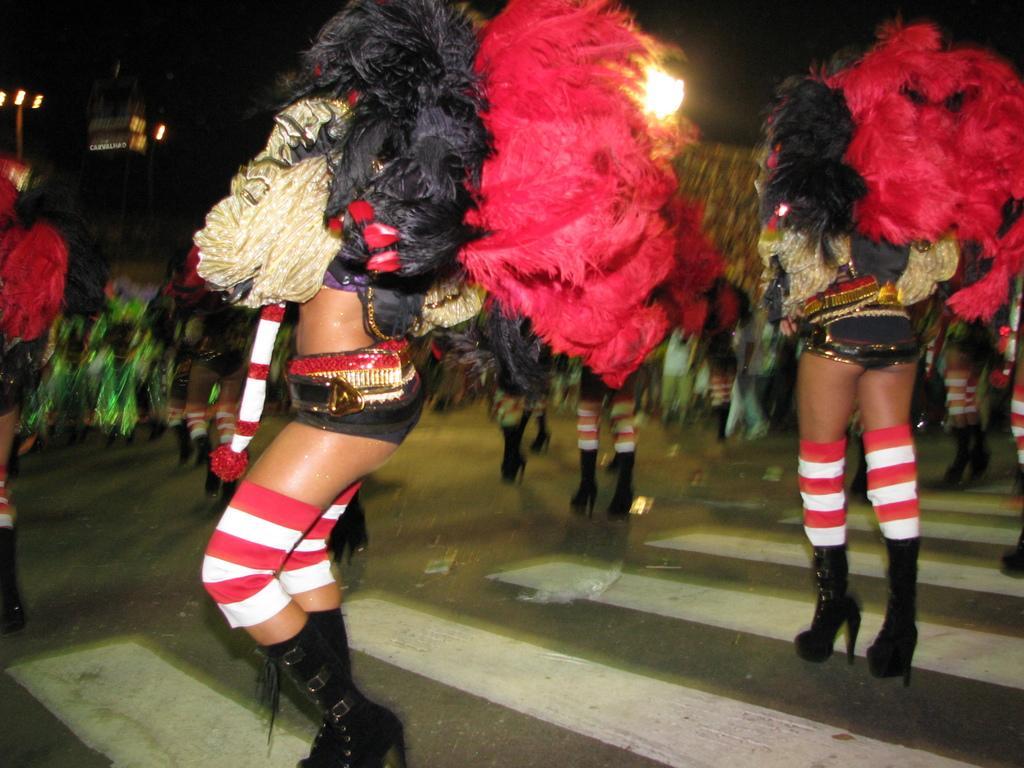Describe this image in one or two sentences. In this image we can see ladies. They are all dressed in the costumes. In the bottom there is a road. In the background there are poles and lights. 